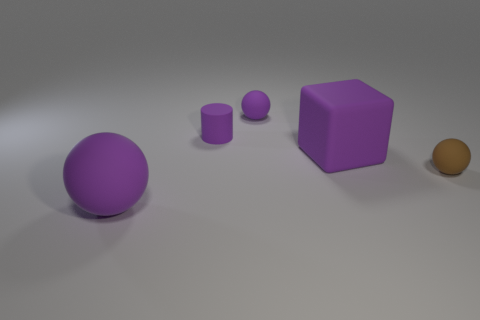Subtract all green balls. Subtract all yellow blocks. How many balls are left? 3 Add 2 big objects. How many objects exist? 7 Subtract all blocks. How many objects are left? 4 Add 3 matte cylinders. How many matte cylinders exist? 4 Subtract 0 red cylinders. How many objects are left? 5 Subtract all large matte objects. Subtract all tiny purple matte balls. How many objects are left? 2 Add 5 purple blocks. How many purple blocks are left? 6 